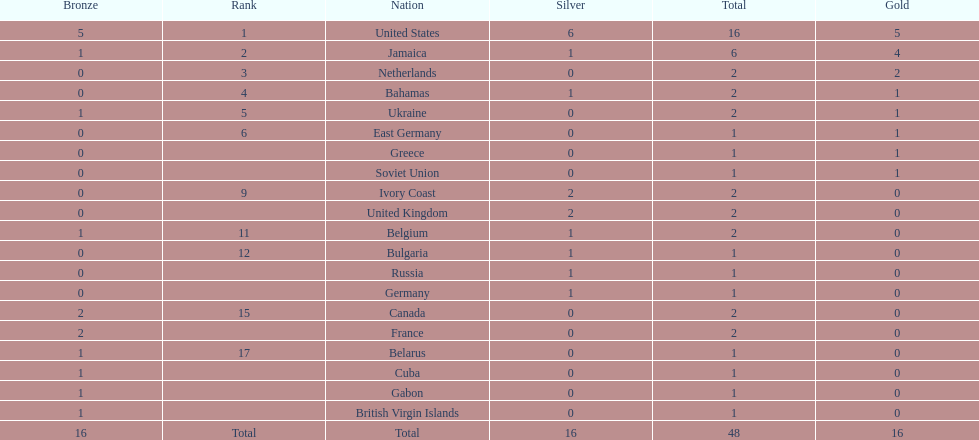What is the overall count of gold medals jamaica has secured? 4. 